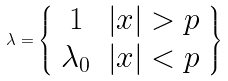<formula> <loc_0><loc_0><loc_500><loc_500>\lambda = \left \{ \begin{array} { c l r r } 1 & \left | x \right | > p \\ \lambda _ { 0 } & \left | x \right | < p \end{array} \right \}</formula> 